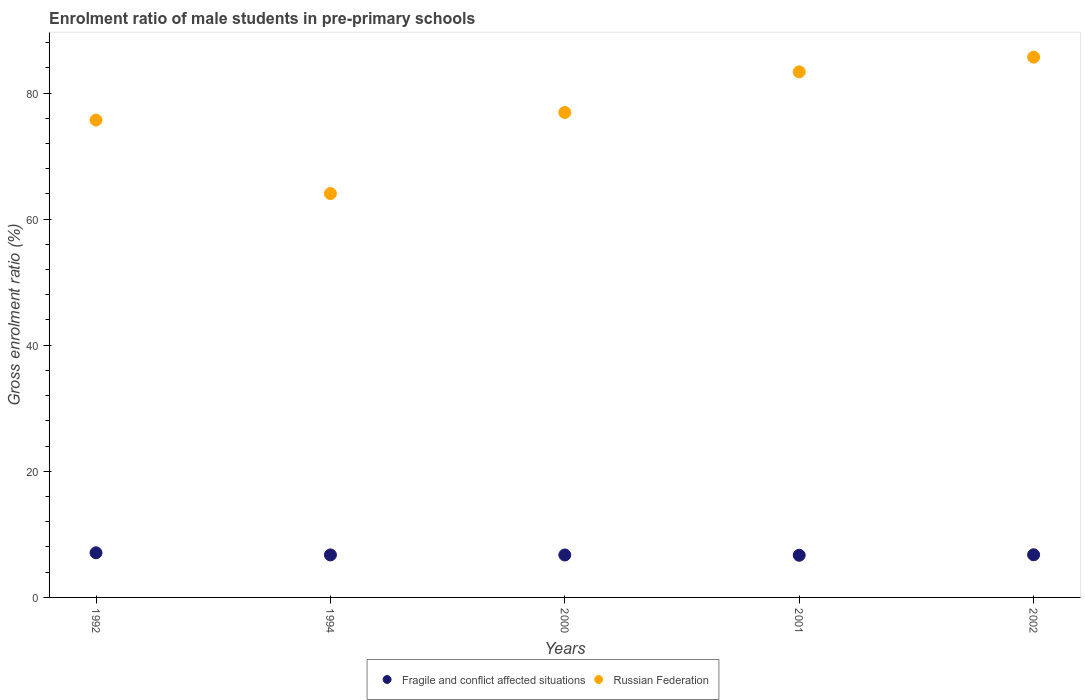Is the number of dotlines equal to the number of legend labels?
Your answer should be very brief. Yes. What is the enrolment ratio of male students in pre-primary schools in Russian Federation in 1994?
Your answer should be very brief. 64.06. Across all years, what is the maximum enrolment ratio of male students in pre-primary schools in Russian Federation?
Your answer should be compact. 85.69. Across all years, what is the minimum enrolment ratio of male students in pre-primary schools in Fragile and conflict affected situations?
Offer a terse response. 6.69. In which year was the enrolment ratio of male students in pre-primary schools in Russian Federation maximum?
Offer a very short reply. 2002. What is the total enrolment ratio of male students in pre-primary schools in Fragile and conflict affected situations in the graph?
Offer a terse response. 34. What is the difference between the enrolment ratio of male students in pre-primary schools in Russian Federation in 1994 and that in 2002?
Offer a terse response. -21.63. What is the difference between the enrolment ratio of male students in pre-primary schools in Russian Federation in 2002 and the enrolment ratio of male students in pre-primary schools in Fragile and conflict affected situations in 1994?
Make the answer very short. 78.95. What is the average enrolment ratio of male students in pre-primary schools in Fragile and conflict affected situations per year?
Your answer should be very brief. 6.8. In the year 1994, what is the difference between the enrolment ratio of male students in pre-primary schools in Fragile and conflict affected situations and enrolment ratio of male students in pre-primary schools in Russian Federation?
Your response must be concise. -57.32. What is the ratio of the enrolment ratio of male students in pre-primary schools in Fragile and conflict affected situations in 1994 to that in 2001?
Your response must be concise. 1.01. What is the difference between the highest and the second highest enrolment ratio of male students in pre-primary schools in Fragile and conflict affected situations?
Make the answer very short. 0.31. What is the difference between the highest and the lowest enrolment ratio of male students in pre-primary schools in Fragile and conflict affected situations?
Provide a short and direct response. 0.39. Is the sum of the enrolment ratio of male students in pre-primary schools in Fragile and conflict affected situations in 2001 and 2002 greater than the maximum enrolment ratio of male students in pre-primary schools in Russian Federation across all years?
Your answer should be very brief. No. Is the enrolment ratio of male students in pre-primary schools in Fragile and conflict affected situations strictly less than the enrolment ratio of male students in pre-primary schools in Russian Federation over the years?
Your answer should be very brief. Yes. How many years are there in the graph?
Offer a terse response. 5. Does the graph contain any zero values?
Provide a short and direct response. No. Does the graph contain grids?
Provide a short and direct response. No. Where does the legend appear in the graph?
Keep it short and to the point. Bottom center. How many legend labels are there?
Provide a succinct answer. 2. How are the legend labels stacked?
Your answer should be compact. Horizontal. What is the title of the graph?
Ensure brevity in your answer.  Enrolment ratio of male students in pre-primary schools. What is the label or title of the X-axis?
Your response must be concise. Years. What is the label or title of the Y-axis?
Your response must be concise. Gross enrolment ratio (%). What is the Gross enrolment ratio (%) in Fragile and conflict affected situations in 1992?
Provide a succinct answer. 7.08. What is the Gross enrolment ratio (%) of Russian Federation in 1992?
Make the answer very short. 75.71. What is the Gross enrolment ratio (%) in Fragile and conflict affected situations in 1994?
Your answer should be very brief. 6.74. What is the Gross enrolment ratio (%) in Russian Federation in 1994?
Make the answer very short. 64.06. What is the Gross enrolment ratio (%) in Fragile and conflict affected situations in 2000?
Provide a short and direct response. 6.73. What is the Gross enrolment ratio (%) of Russian Federation in 2000?
Provide a succinct answer. 76.91. What is the Gross enrolment ratio (%) in Fragile and conflict affected situations in 2001?
Your response must be concise. 6.69. What is the Gross enrolment ratio (%) in Russian Federation in 2001?
Keep it short and to the point. 83.36. What is the Gross enrolment ratio (%) in Fragile and conflict affected situations in 2002?
Give a very brief answer. 6.77. What is the Gross enrolment ratio (%) in Russian Federation in 2002?
Keep it short and to the point. 85.69. Across all years, what is the maximum Gross enrolment ratio (%) of Fragile and conflict affected situations?
Provide a short and direct response. 7.08. Across all years, what is the maximum Gross enrolment ratio (%) of Russian Federation?
Your response must be concise. 85.69. Across all years, what is the minimum Gross enrolment ratio (%) of Fragile and conflict affected situations?
Make the answer very short. 6.69. Across all years, what is the minimum Gross enrolment ratio (%) of Russian Federation?
Make the answer very short. 64.06. What is the total Gross enrolment ratio (%) of Fragile and conflict affected situations in the graph?
Offer a very short reply. 34. What is the total Gross enrolment ratio (%) in Russian Federation in the graph?
Offer a very short reply. 385.72. What is the difference between the Gross enrolment ratio (%) of Fragile and conflict affected situations in 1992 and that in 1994?
Give a very brief answer. 0.34. What is the difference between the Gross enrolment ratio (%) in Russian Federation in 1992 and that in 1994?
Ensure brevity in your answer.  11.65. What is the difference between the Gross enrolment ratio (%) of Fragile and conflict affected situations in 1992 and that in 2000?
Offer a very short reply. 0.34. What is the difference between the Gross enrolment ratio (%) in Russian Federation in 1992 and that in 2000?
Your response must be concise. -1.2. What is the difference between the Gross enrolment ratio (%) in Fragile and conflict affected situations in 1992 and that in 2001?
Your response must be concise. 0.39. What is the difference between the Gross enrolment ratio (%) in Russian Federation in 1992 and that in 2001?
Provide a short and direct response. -7.65. What is the difference between the Gross enrolment ratio (%) of Fragile and conflict affected situations in 1992 and that in 2002?
Ensure brevity in your answer.  0.31. What is the difference between the Gross enrolment ratio (%) of Russian Federation in 1992 and that in 2002?
Offer a very short reply. -9.98. What is the difference between the Gross enrolment ratio (%) in Fragile and conflict affected situations in 1994 and that in 2000?
Your answer should be very brief. 0.01. What is the difference between the Gross enrolment ratio (%) of Russian Federation in 1994 and that in 2000?
Make the answer very short. -12.86. What is the difference between the Gross enrolment ratio (%) of Fragile and conflict affected situations in 1994 and that in 2001?
Your response must be concise. 0.05. What is the difference between the Gross enrolment ratio (%) of Russian Federation in 1994 and that in 2001?
Make the answer very short. -19.3. What is the difference between the Gross enrolment ratio (%) of Fragile and conflict affected situations in 1994 and that in 2002?
Ensure brevity in your answer.  -0.02. What is the difference between the Gross enrolment ratio (%) in Russian Federation in 1994 and that in 2002?
Your answer should be very brief. -21.63. What is the difference between the Gross enrolment ratio (%) in Fragile and conflict affected situations in 2000 and that in 2001?
Provide a succinct answer. 0.05. What is the difference between the Gross enrolment ratio (%) in Russian Federation in 2000 and that in 2001?
Offer a terse response. -6.44. What is the difference between the Gross enrolment ratio (%) of Fragile and conflict affected situations in 2000 and that in 2002?
Give a very brief answer. -0.03. What is the difference between the Gross enrolment ratio (%) in Russian Federation in 2000 and that in 2002?
Provide a short and direct response. -8.77. What is the difference between the Gross enrolment ratio (%) in Fragile and conflict affected situations in 2001 and that in 2002?
Offer a very short reply. -0.08. What is the difference between the Gross enrolment ratio (%) in Russian Federation in 2001 and that in 2002?
Ensure brevity in your answer.  -2.33. What is the difference between the Gross enrolment ratio (%) in Fragile and conflict affected situations in 1992 and the Gross enrolment ratio (%) in Russian Federation in 1994?
Keep it short and to the point. -56.98. What is the difference between the Gross enrolment ratio (%) in Fragile and conflict affected situations in 1992 and the Gross enrolment ratio (%) in Russian Federation in 2000?
Provide a succinct answer. -69.84. What is the difference between the Gross enrolment ratio (%) of Fragile and conflict affected situations in 1992 and the Gross enrolment ratio (%) of Russian Federation in 2001?
Offer a terse response. -76.28. What is the difference between the Gross enrolment ratio (%) in Fragile and conflict affected situations in 1992 and the Gross enrolment ratio (%) in Russian Federation in 2002?
Provide a short and direct response. -78.61. What is the difference between the Gross enrolment ratio (%) of Fragile and conflict affected situations in 1994 and the Gross enrolment ratio (%) of Russian Federation in 2000?
Give a very brief answer. -70.17. What is the difference between the Gross enrolment ratio (%) of Fragile and conflict affected situations in 1994 and the Gross enrolment ratio (%) of Russian Federation in 2001?
Your answer should be very brief. -76.62. What is the difference between the Gross enrolment ratio (%) in Fragile and conflict affected situations in 1994 and the Gross enrolment ratio (%) in Russian Federation in 2002?
Offer a terse response. -78.95. What is the difference between the Gross enrolment ratio (%) of Fragile and conflict affected situations in 2000 and the Gross enrolment ratio (%) of Russian Federation in 2001?
Offer a very short reply. -76.62. What is the difference between the Gross enrolment ratio (%) in Fragile and conflict affected situations in 2000 and the Gross enrolment ratio (%) in Russian Federation in 2002?
Offer a very short reply. -78.95. What is the difference between the Gross enrolment ratio (%) in Fragile and conflict affected situations in 2001 and the Gross enrolment ratio (%) in Russian Federation in 2002?
Keep it short and to the point. -79. What is the average Gross enrolment ratio (%) of Fragile and conflict affected situations per year?
Give a very brief answer. 6.8. What is the average Gross enrolment ratio (%) in Russian Federation per year?
Your answer should be very brief. 77.14. In the year 1992, what is the difference between the Gross enrolment ratio (%) in Fragile and conflict affected situations and Gross enrolment ratio (%) in Russian Federation?
Offer a very short reply. -68.63. In the year 1994, what is the difference between the Gross enrolment ratio (%) in Fragile and conflict affected situations and Gross enrolment ratio (%) in Russian Federation?
Provide a succinct answer. -57.32. In the year 2000, what is the difference between the Gross enrolment ratio (%) of Fragile and conflict affected situations and Gross enrolment ratio (%) of Russian Federation?
Your response must be concise. -70.18. In the year 2001, what is the difference between the Gross enrolment ratio (%) of Fragile and conflict affected situations and Gross enrolment ratio (%) of Russian Federation?
Keep it short and to the point. -76.67. In the year 2002, what is the difference between the Gross enrolment ratio (%) of Fragile and conflict affected situations and Gross enrolment ratio (%) of Russian Federation?
Ensure brevity in your answer.  -78.92. What is the ratio of the Gross enrolment ratio (%) in Fragile and conflict affected situations in 1992 to that in 1994?
Your response must be concise. 1.05. What is the ratio of the Gross enrolment ratio (%) of Russian Federation in 1992 to that in 1994?
Your answer should be compact. 1.18. What is the ratio of the Gross enrolment ratio (%) of Fragile and conflict affected situations in 1992 to that in 2000?
Keep it short and to the point. 1.05. What is the ratio of the Gross enrolment ratio (%) of Russian Federation in 1992 to that in 2000?
Provide a short and direct response. 0.98. What is the ratio of the Gross enrolment ratio (%) of Fragile and conflict affected situations in 1992 to that in 2001?
Give a very brief answer. 1.06. What is the ratio of the Gross enrolment ratio (%) of Russian Federation in 1992 to that in 2001?
Provide a succinct answer. 0.91. What is the ratio of the Gross enrolment ratio (%) in Fragile and conflict affected situations in 1992 to that in 2002?
Give a very brief answer. 1.05. What is the ratio of the Gross enrolment ratio (%) in Russian Federation in 1992 to that in 2002?
Keep it short and to the point. 0.88. What is the ratio of the Gross enrolment ratio (%) of Russian Federation in 1994 to that in 2000?
Give a very brief answer. 0.83. What is the ratio of the Gross enrolment ratio (%) in Russian Federation in 1994 to that in 2001?
Offer a terse response. 0.77. What is the ratio of the Gross enrolment ratio (%) in Fragile and conflict affected situations in 1994 to that in 2002?
Your answer should be compact. 1. What is the ratio of the Gross enrolment ratio (%) of Russian Federation in 1994 to that in 2002?
Provide a short and direct response. 0.75. What is the ratio of the Gross enrolment ratio (%) of Russian Federation in 2000 to that in 2001?
Your response must be concise. 0.92. What is the ratio of the Gross enrolment ratio (%) in Russian Federation in 2000 to that in 2002?
Your answer should be compact. 0.9. What is the ratio of the Gross enrolment ratio (%) in Russian Federation in 2001 to that in 2002?
Ensure brevity in your answer.  0.97. What is the difference between the highest and the second highest Gross enrolment ratio (%) in Fragile and conflict affected situations?
Your response must be concise. 0.31. What is the difference between the highest and the second highest Gross enrolment ratio (%) of Russian Federation?
Offer a very short reply. 2.33. What is the difference between the highest and the lowest Gross enrolment ratio (%) of Fragile and conflict affected situations?
Your answer should be compact. 0.39. What is the difference between the highest and the lowest Gross enrolment ratio (%) in Russian Federation?
Provide a succinct answer. 21.63. 